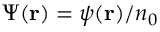Convert formula to latex. <formula><loc_0><loc_0><loc_500><loc_500>\Psi ( { r } ) = \psi ( { r } ) / n _ { 0 }</formula> 